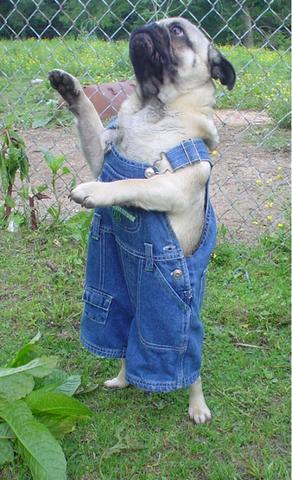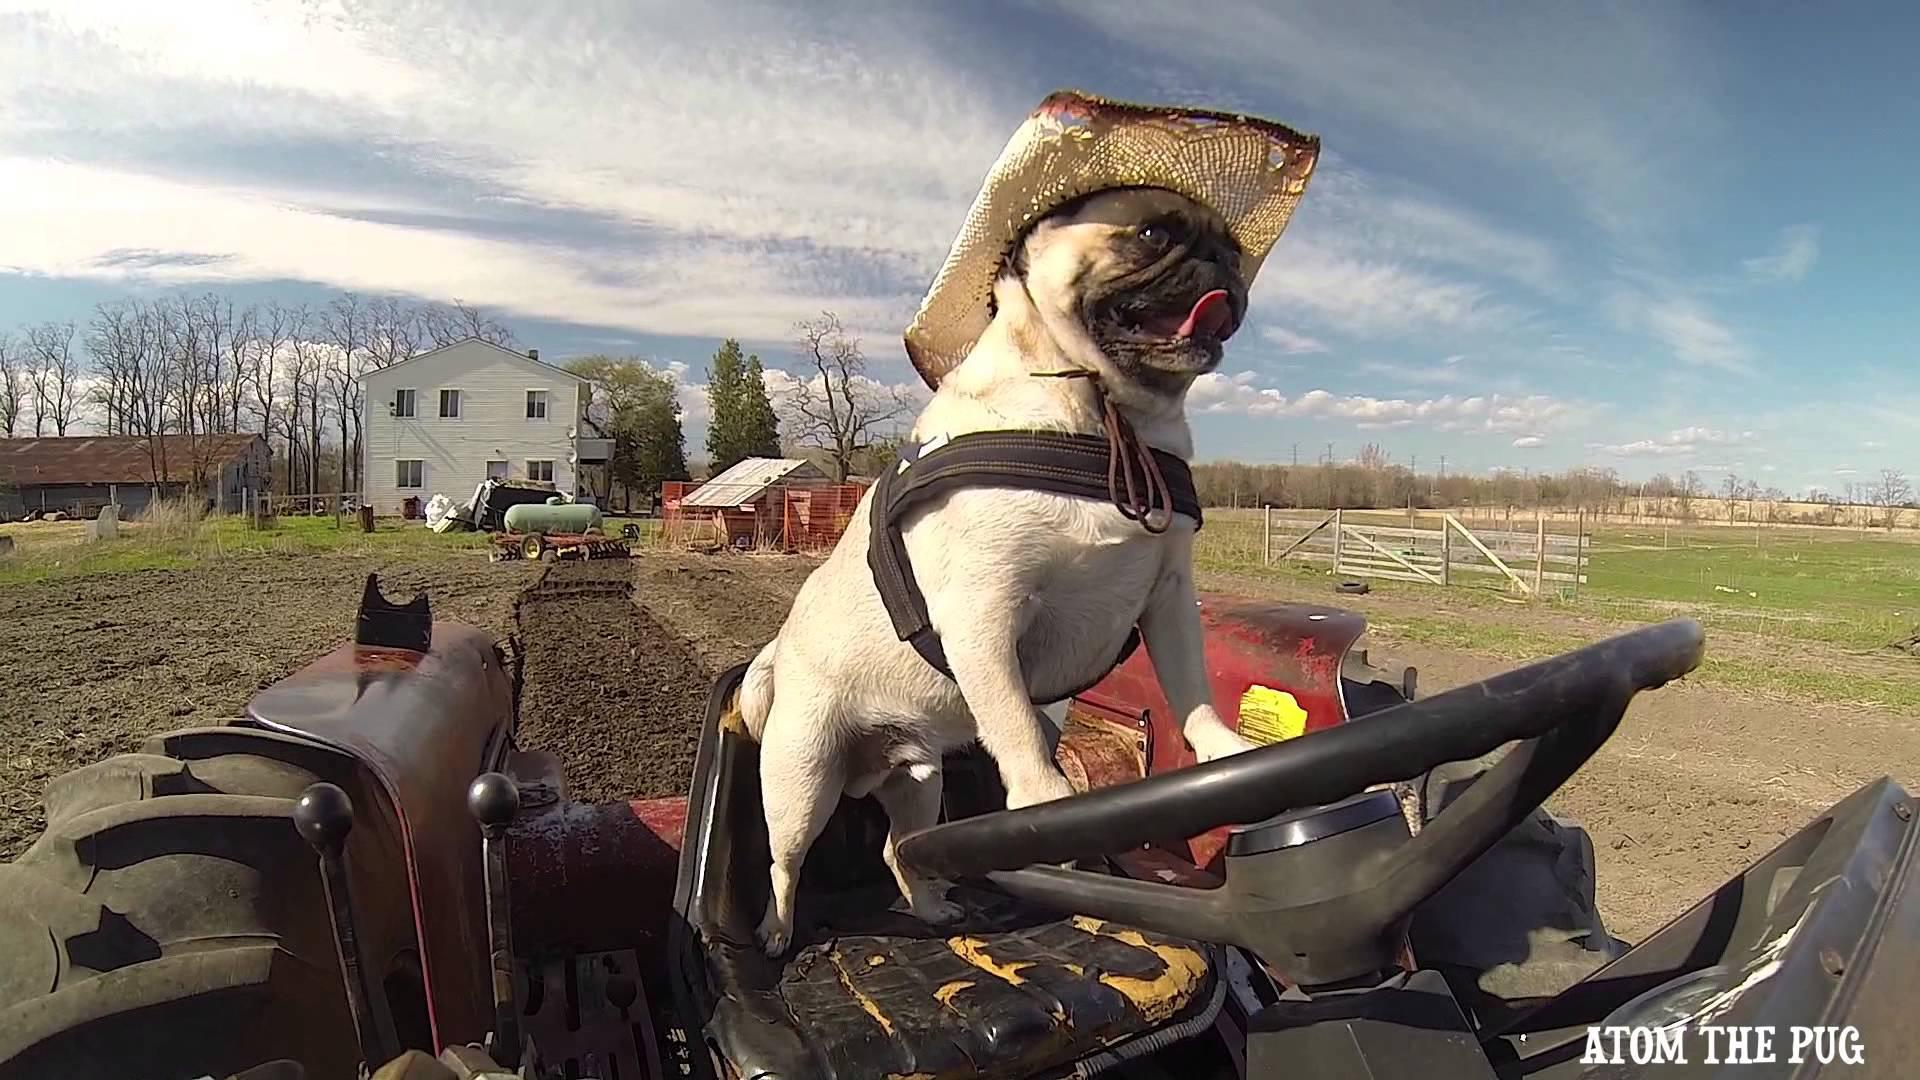The first image is the image on the left, the second image is the image on the right. Given the left and right images, does the statement "At least one of the images contains only a single pug." hold true? Answer yes or no. Yes. The first image is the image on the left, the second image is the image on the right. Examine the images to the left and right. Is the description "In at least one image, at least one pug is wearing clothes." accurate? Answer yes or no. Yes. 